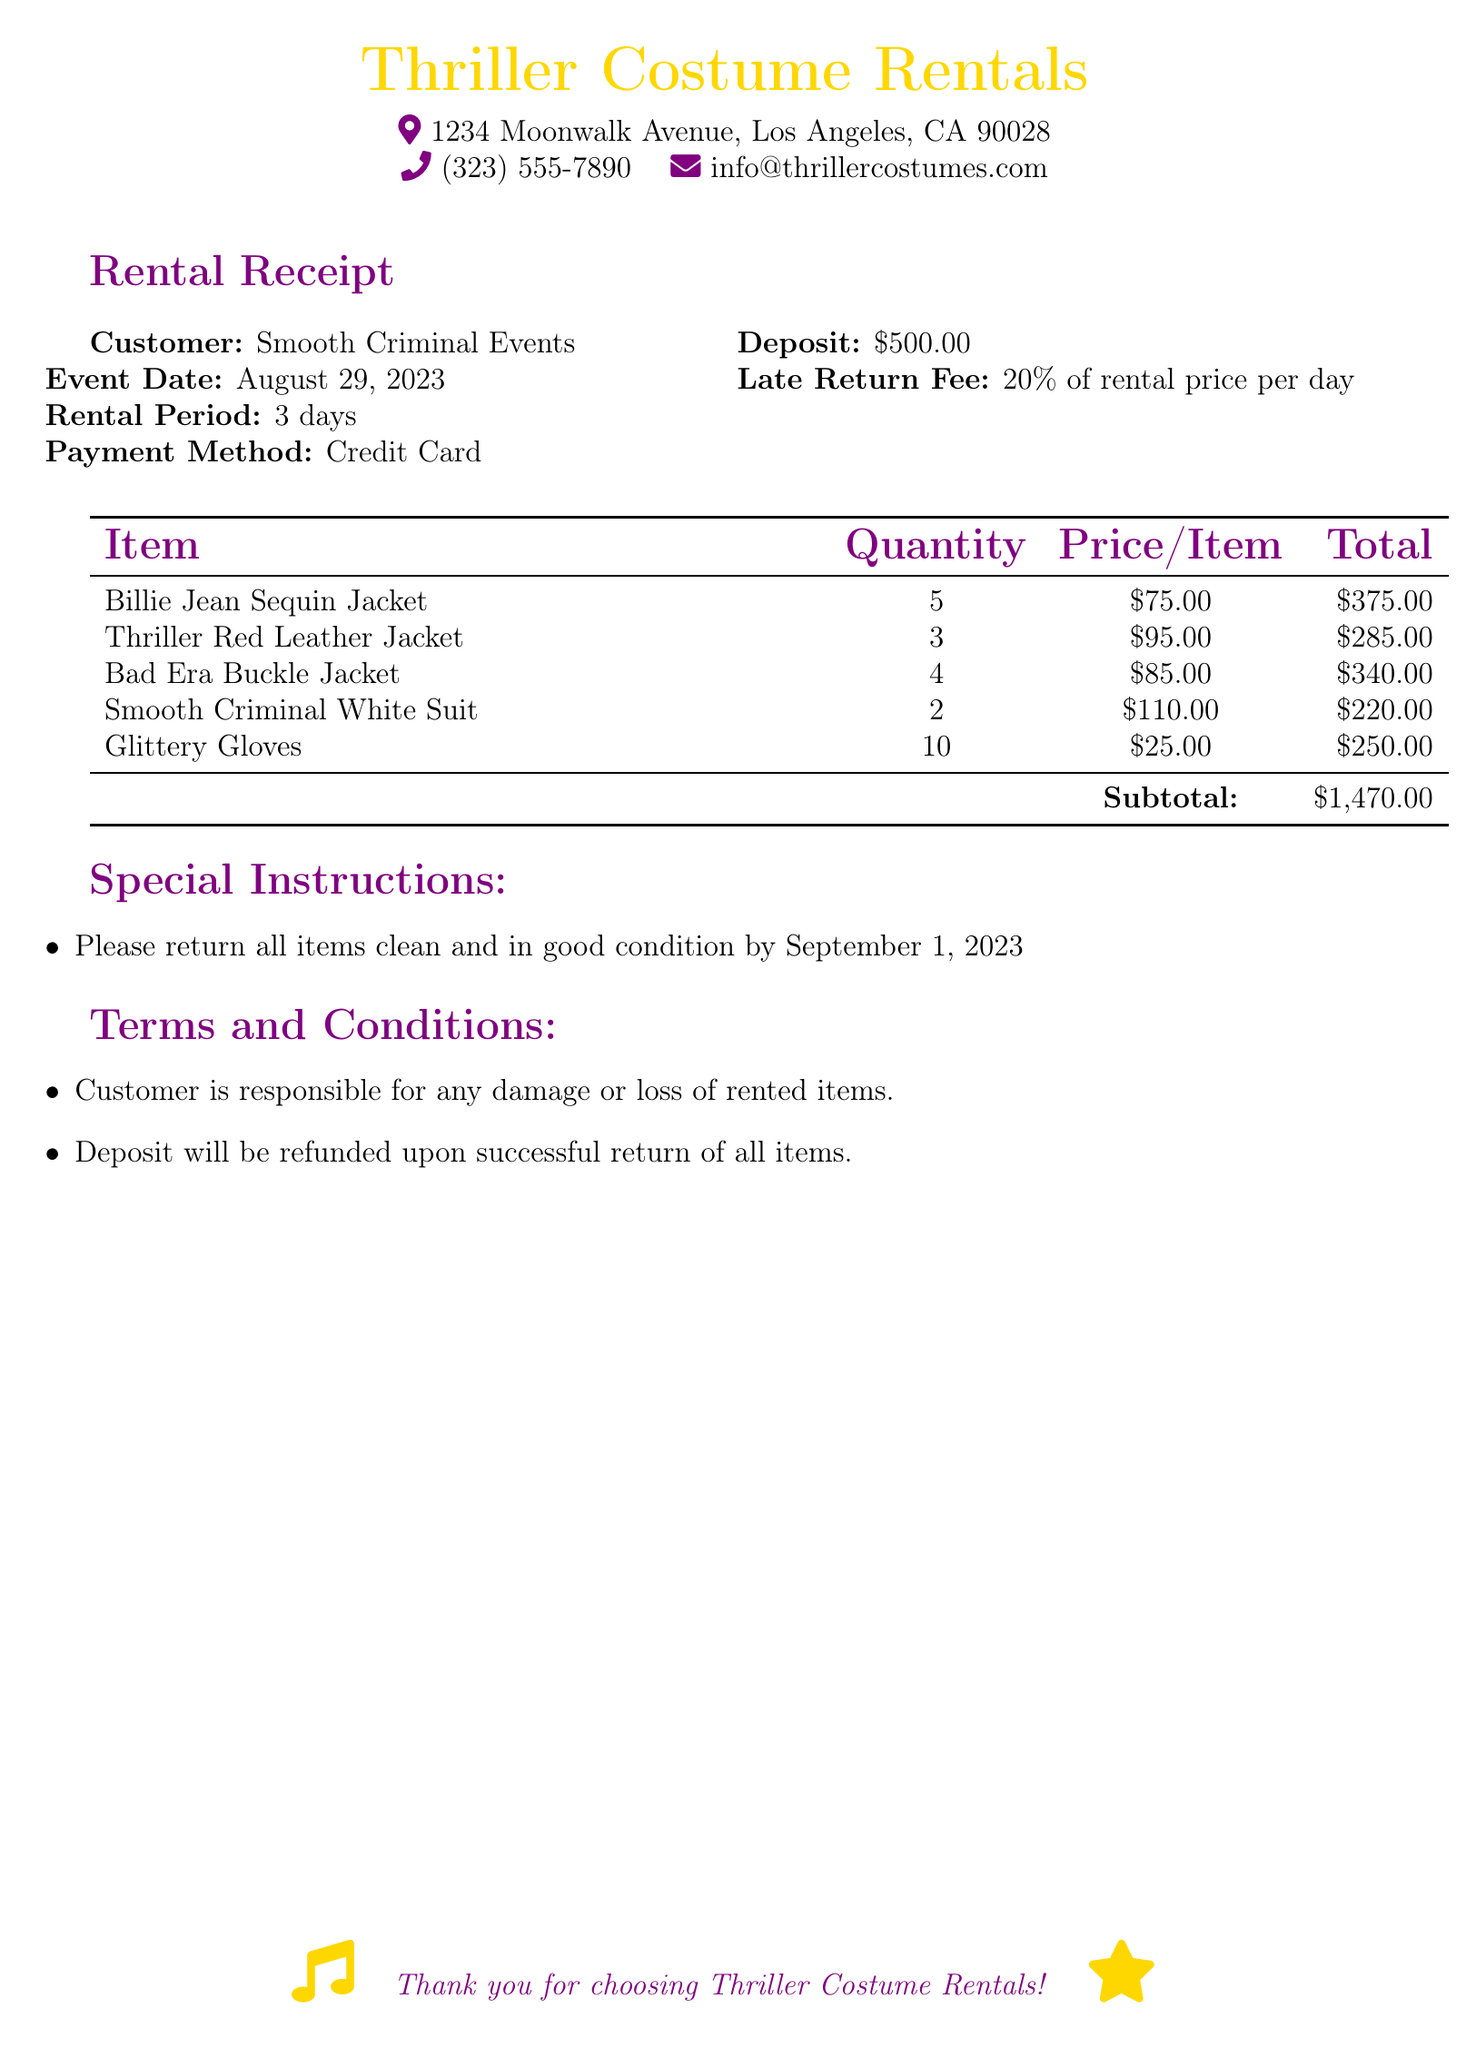What is the customer name? The document states the customer name is Smooth Criminal Events.
Answer: Smooth Criminal Events What is the rental period? The rental period mentioned in the document is for 3 days.
Answer: 3 days When is the event date? The event date specified in the document is August 29, 2023.
Answer: August 29, 2023 What is the total cost of Glittery Gloves? The price per item for Glittery Gloves is $25.00, and the quantity is 10, making the total $250.00.
Answer: $250.00 What is the deposit amount? The document lists the deposit amount as $500.00.
Answer: $500.00 What is the late return fee percentage? The late return fee is stated as 20% of the rental price per day.
Answer: 20% What item has the highest unit price? Based on the prices in the document, the Smooth Criminal White Suit has the highest unit price at $110.00.
Answer: Smooth Criminal White Suit What should be done to the rented items before returning? The special instructions specify that all items should be returned clean and in good condition.
Answer: Clean and in good condition What is the subtotal for the rental items? The subtotal calculated from all items in the document is $1,470.00.
Answer: $1,470.00 